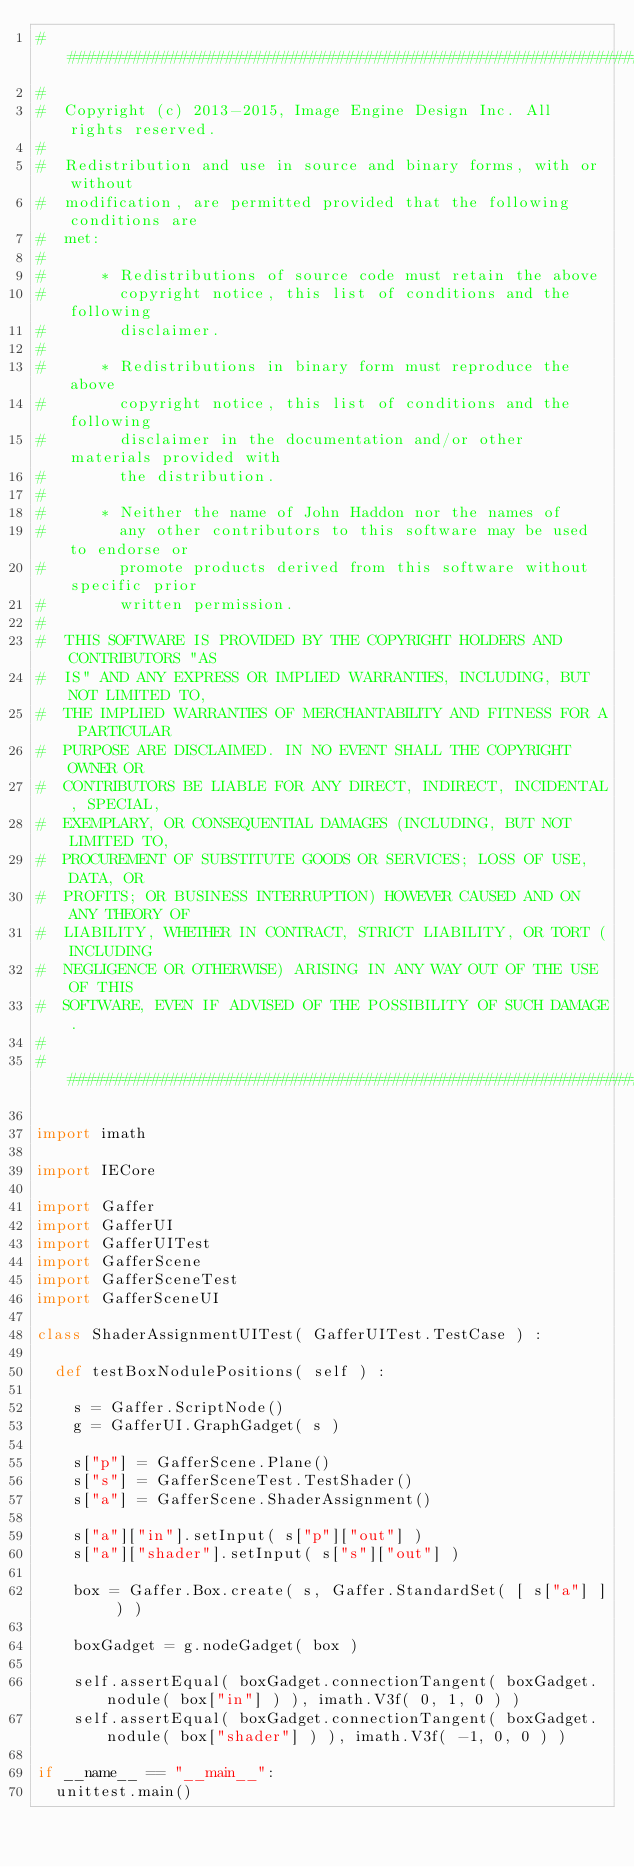<code> <loc_0><loc_0><loc_500><loc_500><_Python_>##########################################################################
#
#  Copyright (c) 2013-2015, Image Engine Design Inc. All rights reserved.
#
#  Redistribution and use in source and binary forms, with or without
#  modification, are permitted provided that the following conditions are
#  met:
#
#      * Redistributions of source code must retain the above
#        copyright notice, this list of conditions and the following
#        disclaimer.
#
#      * Redistributions in binary form must reproduce the above
#        copyright notice, this list of conditions and the following
#        disclaimer in the documentation and/or other materials provided with
#        the distribution.
#
#      * Neither the name of John Haddon nor the names of
#        any other contributors to this software may be used to endorse or
#        promote products derived from this software without specific prior
#        written permission.
#
#  THIS SOFTWARE IS PROVIDED BY THE COPYRIGHT HOLDERS AND CONTRIBUTORS "AS
#  IS" AND ANY EXPRESS OR IMPLIED WARRANTIES, INCLUDING, BUT NOT LIMITED TO,
#  THE IMPLIED WARRANTIES OF MERCHANTABILITY AND FITNESS FOR A PARTICULAR
#  PURPOSE ARE DISCLAIMED. IN NO EVENT SHALL THE COPYRIGHT OWNER OR
#  CONTRIBUTORS BE LIABLE FOR ANY DIRECT, INDIRECT, INCIDENTAL, SPECIAL,
#  EXEMPLARY, OR CONSEQUENTIAL DAMAGES (INCLUDING, BUT NOT LIMITED TO,
#  PROCUREMENT OF SUBSTITUTE GOODS OR SERVICES; LOSS OF USE, DATA, OR
#  PROFITS; OR BUSINESS INTERRUPTION) HOWEVER CAUSED AND ON ANY THEORY OF
#  LIABILITY, WHETHER IN CONTRACT, STRICT LIABILITY, OR TORT (INCLUDING
#  NEGLIGENCE OR OTHERWISE) ARISING IN ANY WAY OUT OF THE USE OF THIS
#  SOFTWARE, EVEN IF ADVISED OF THE POSSIBILITY OF SUCH DAMAGE.
#
##########################################################################

import imath

import IECore

import Gaffer
import GafferUI
import GafferUITest
import GafferScene
import GafferSceneTest
import GafferSceneUI

class ShaderAssignmentUITest( GafferUITest.TestCase ) :

	def testBoxNodulePositions( self ) :

		s = Gaffer.ScriptNode()
		g = GafferUI.GraphGadget( s )

		s["p"] = GafferScene.Plane()
		s["s"] = GafferSceneTest.TestShader()
		s["a"] = GafferScene.ShaderAssignment()

		s["a"]["in"].setInput( s["p"]["out"] )
		s["a"]["shader"].setInput( s["s"]["out"] )

		box = Gaffer.Box.create( s, Gaffer.StandardSet( [ s["a"] ] ) )

		boxGadget = g.nodeGadget( box )

		self.assertEqual( boxGadget.connectionTangent( boxGadget.nodule( box["in"] ) ), imath.V3f( 0, 1, 0 ) )
		self.assertEqual( boxGadget.connectionTangent( boxGadget.nodule( box["shader"] ) ), imath.V3f( -1, 0, 0 ) )

if __name__ == "__main__":
	unittest.main()
</code> 